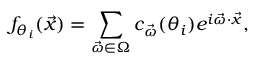Convert formula to latex. <formula><loc_0><loc_0><loc_500><loc_500>f _ { \theta _ { i } } ( \vec { x } ) = \sum _ { \ V e c { \omega } \in \Omega } c _ { \vec { \omega } } ( \theta _ { i } ) e ^ { i \vec { \omega } \cdot \vec { x } } ,</formula> 